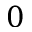Convert formula to latex. <formula><loc_0><loc_0><loc_500><loc_500>0</formula> 